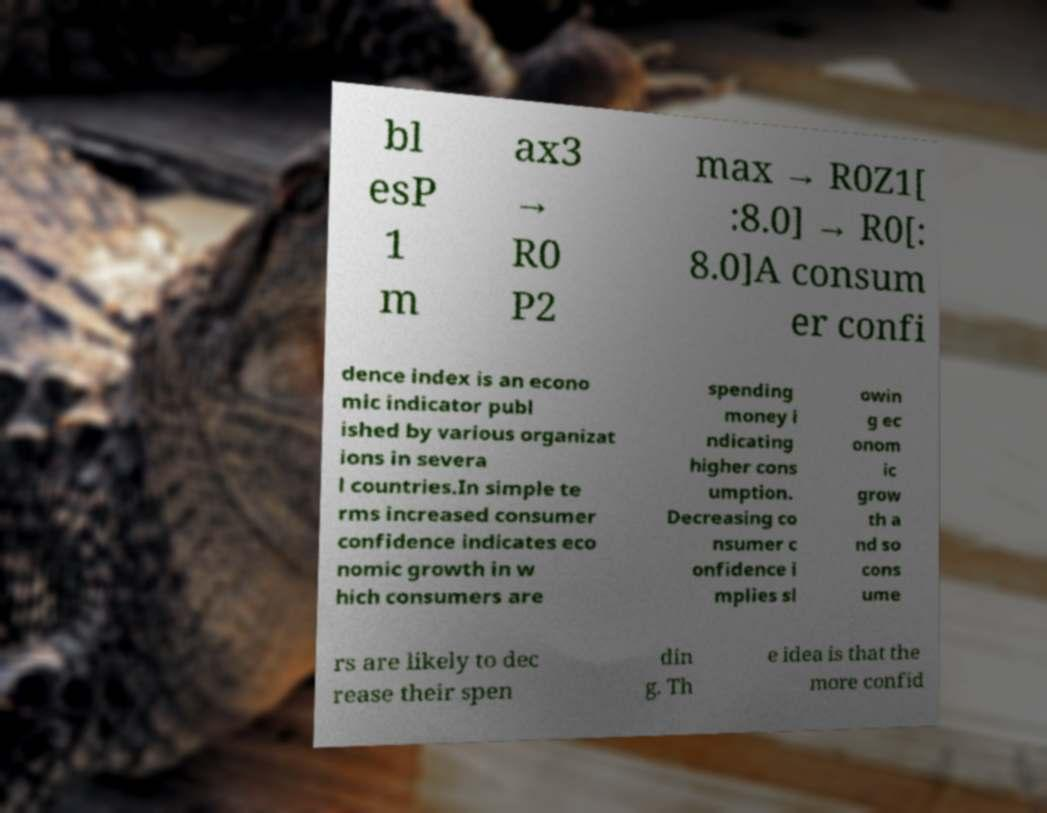There's text embedded in this image that I need extracted. Can you transcribe it verbatim? bl esP 1 m ax3 → R0 P2 max → R0Z1[ :8.0] → R0[: 8.0]A consum er confi dence index is an econo mic indicator publ ished by various organizat ions in severa l countries.In simple te rms increased consumer confidence indicates eco nomic growth in w hich consumers are spending money i ndicating higher cons umption. Decreasing co nsumer c onfidence i mplies sl owin g ec onom ic grow th a nd so cons ume rs are likely to dec rease their spen din g. Th e idea is that the more confid 